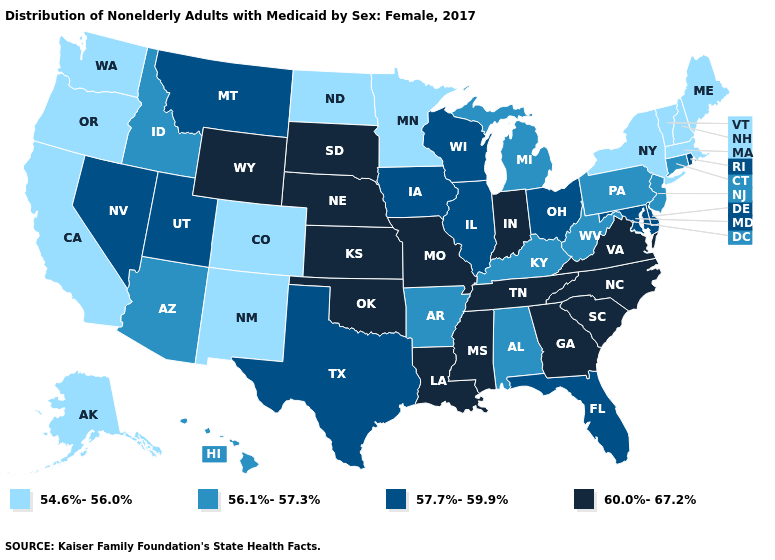Among the states that border Georgia , does Alabama have the lowest value?
Answer briefly. Yes. Name the states that have a value in the range 56.1%-57.3%?
Write a very short answer. Alabama, Arizona, Arkansas, Connecticut, Hawaii, Idaho, Kentucky, Michigan, New Jersey, Pennsylvania, West Virginia. What is the value of Delaware?
Give a very brief answer. 57.7%-59.9%. What is the value of Delaware?
Concise answer only. 57.7%-59.9%. Does Delaware have a lower value than Connecticut?
Keep it brief. No. What is the value of Alaska?
Be succinct. 54.6%-56.0%. What is the value of Missouri?
Short answer required. 60.0%-67.2%. How many symbols are there in the legend?
Keep it brief. 4. Among the states that border New York , which have the highest value?
Keep it brief. Connecticut, New Jersey, Pennsylvania. Name the states that have a value in the range 54.6%-56.0%?
Concise answer only. Alaska, California, Colorado, Maine, Massachusetts, Minnesota, New Hampshire, New Mexico, New York, North Dakota, Oregon, Vermont, Washington. Name the states that have a value in the range 57.7%-59.9%?
Write a very short answer. Delaware, Florida, Illinois, Iowa, Maryland, Montana, Nevada, Ohio, Rhode Island, Texas, Utah, Wisconsin. Name the states that have a value in the range 60.0%-67.2%?
Write a very short answer. Georgia, Indiana, Kansas, Louisiana, Mississippi, Missouri, Nebraska, North Carolina, Oklahoma, South Carolina, South Dakota, Tennessee, Virginia, Wyoming. Does Washington have a lower value than Utah?
Answer briefly. Yes. What is the value of Alaska?
Answer briefly. 54.6%-56.0%. Name the states that have a value in the range 56.1%-57.3%?
Keep it brief. Alabama, Arizona, Arkansas, Connecticut, Hawaii, Idaho, Kentucky, Michigan, New Jersey, Pennsylvania, West Virginia. 